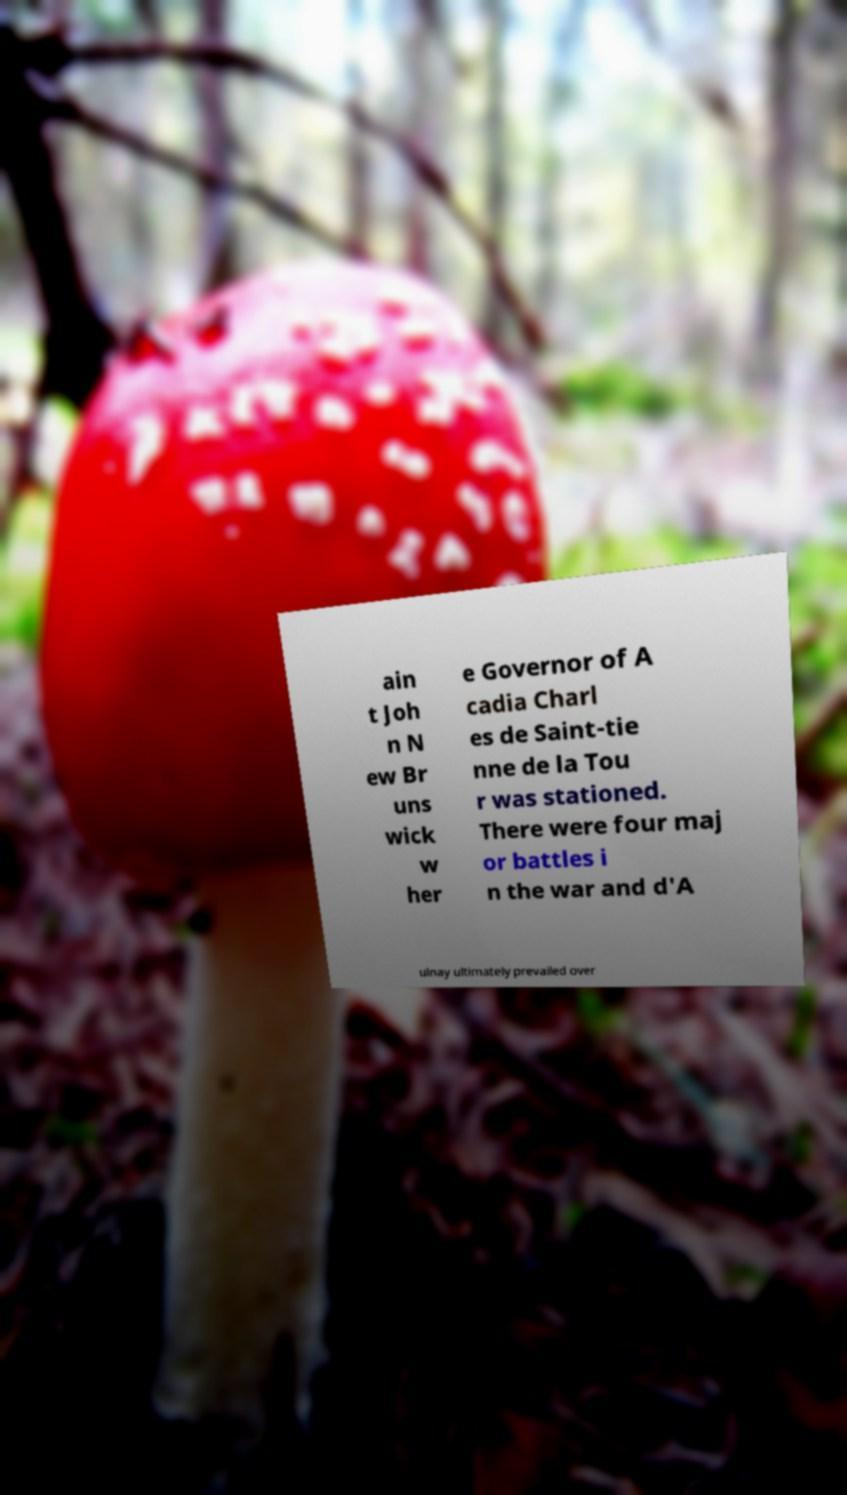Can you accurately transcribe the text from the provided image for me? ain t Joh n N ew Br uns wick w her e Governor of A cadia Charl es de Saint-tie nne de la Tou r was stationed. There were four maj or battles i n the war and d'A ulnay ultimately prevailed over 